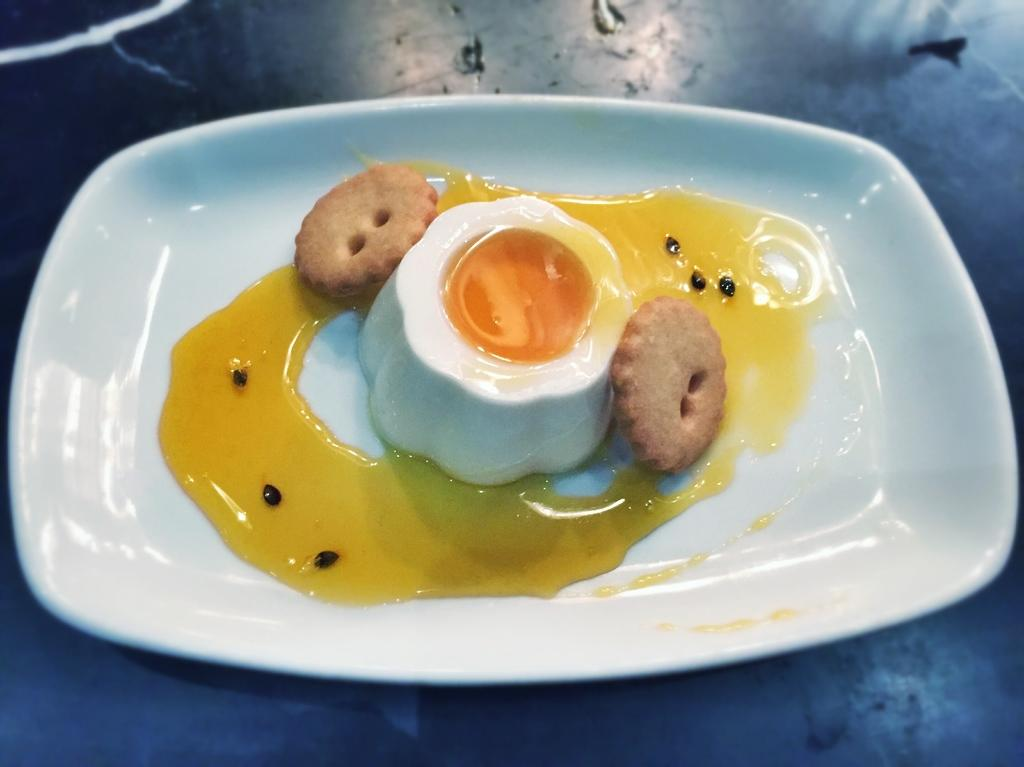What types of items are present in the image? There are food items in the image. What is the color of the plate on which the food items are placed? The plate is white in color. What type of appliance is visible in the image? There is no appliance present in the image. What color is the underwear worn by the person in the image? There is no person or underwear visible in the image. 